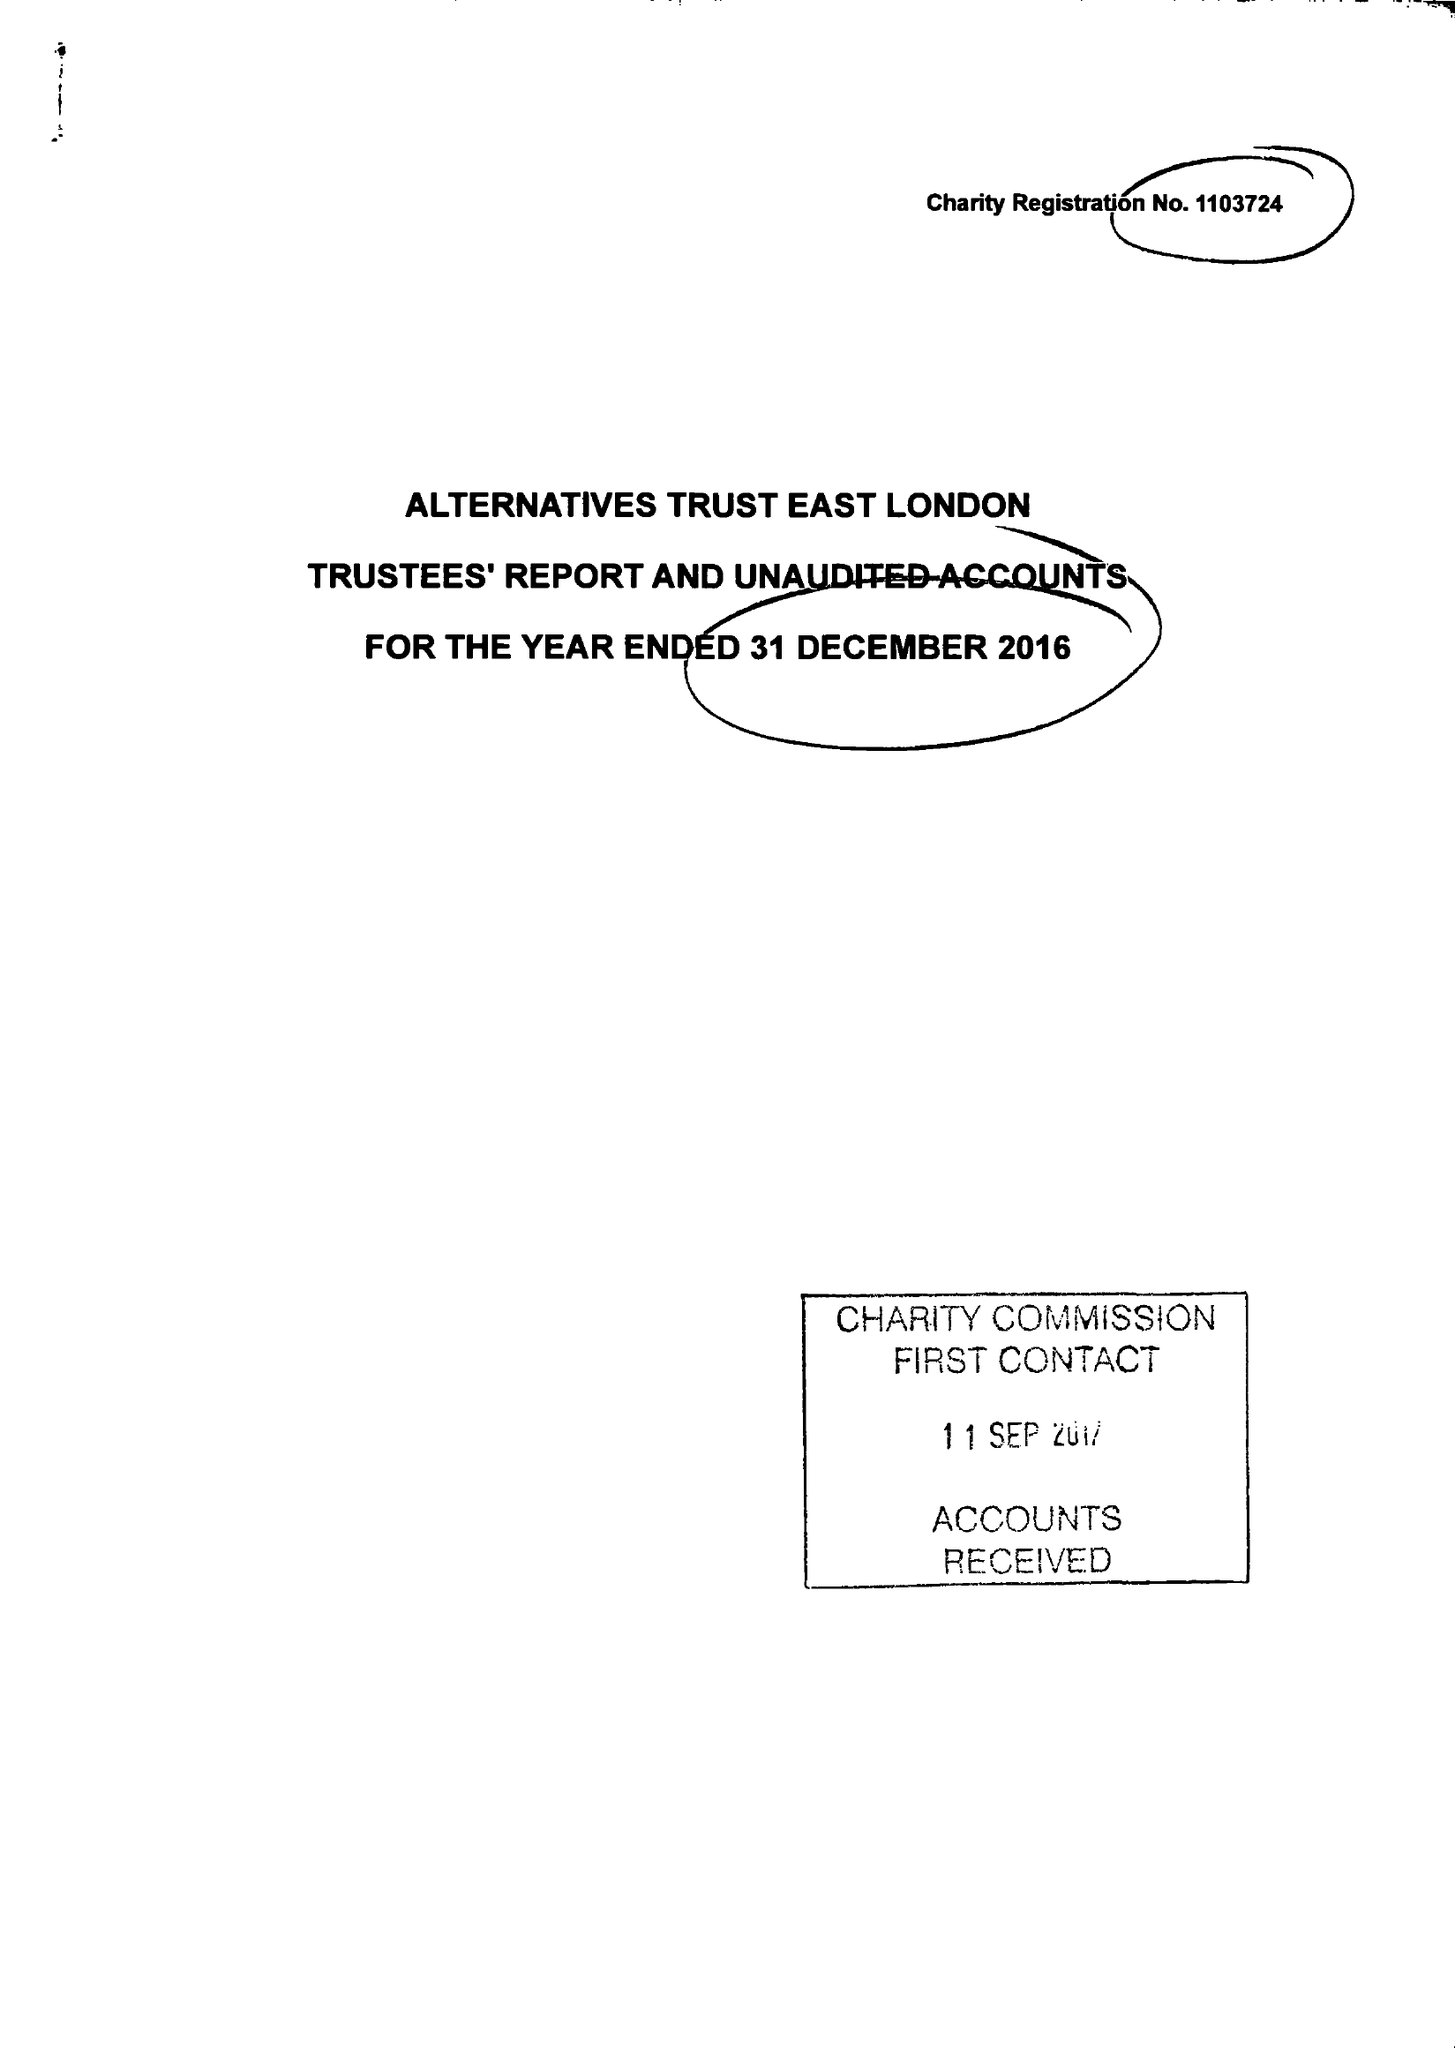What is the value for the report_date?
Answer the question using a single word or phrase. 2016-12-31 